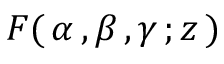Convert formula to latex. <formula><loc_0><loc_0><loc_500><loc_500>\, F ( \, \alpha \, , \beta \, , \gamma \, ; z \, ) \,</formula> 